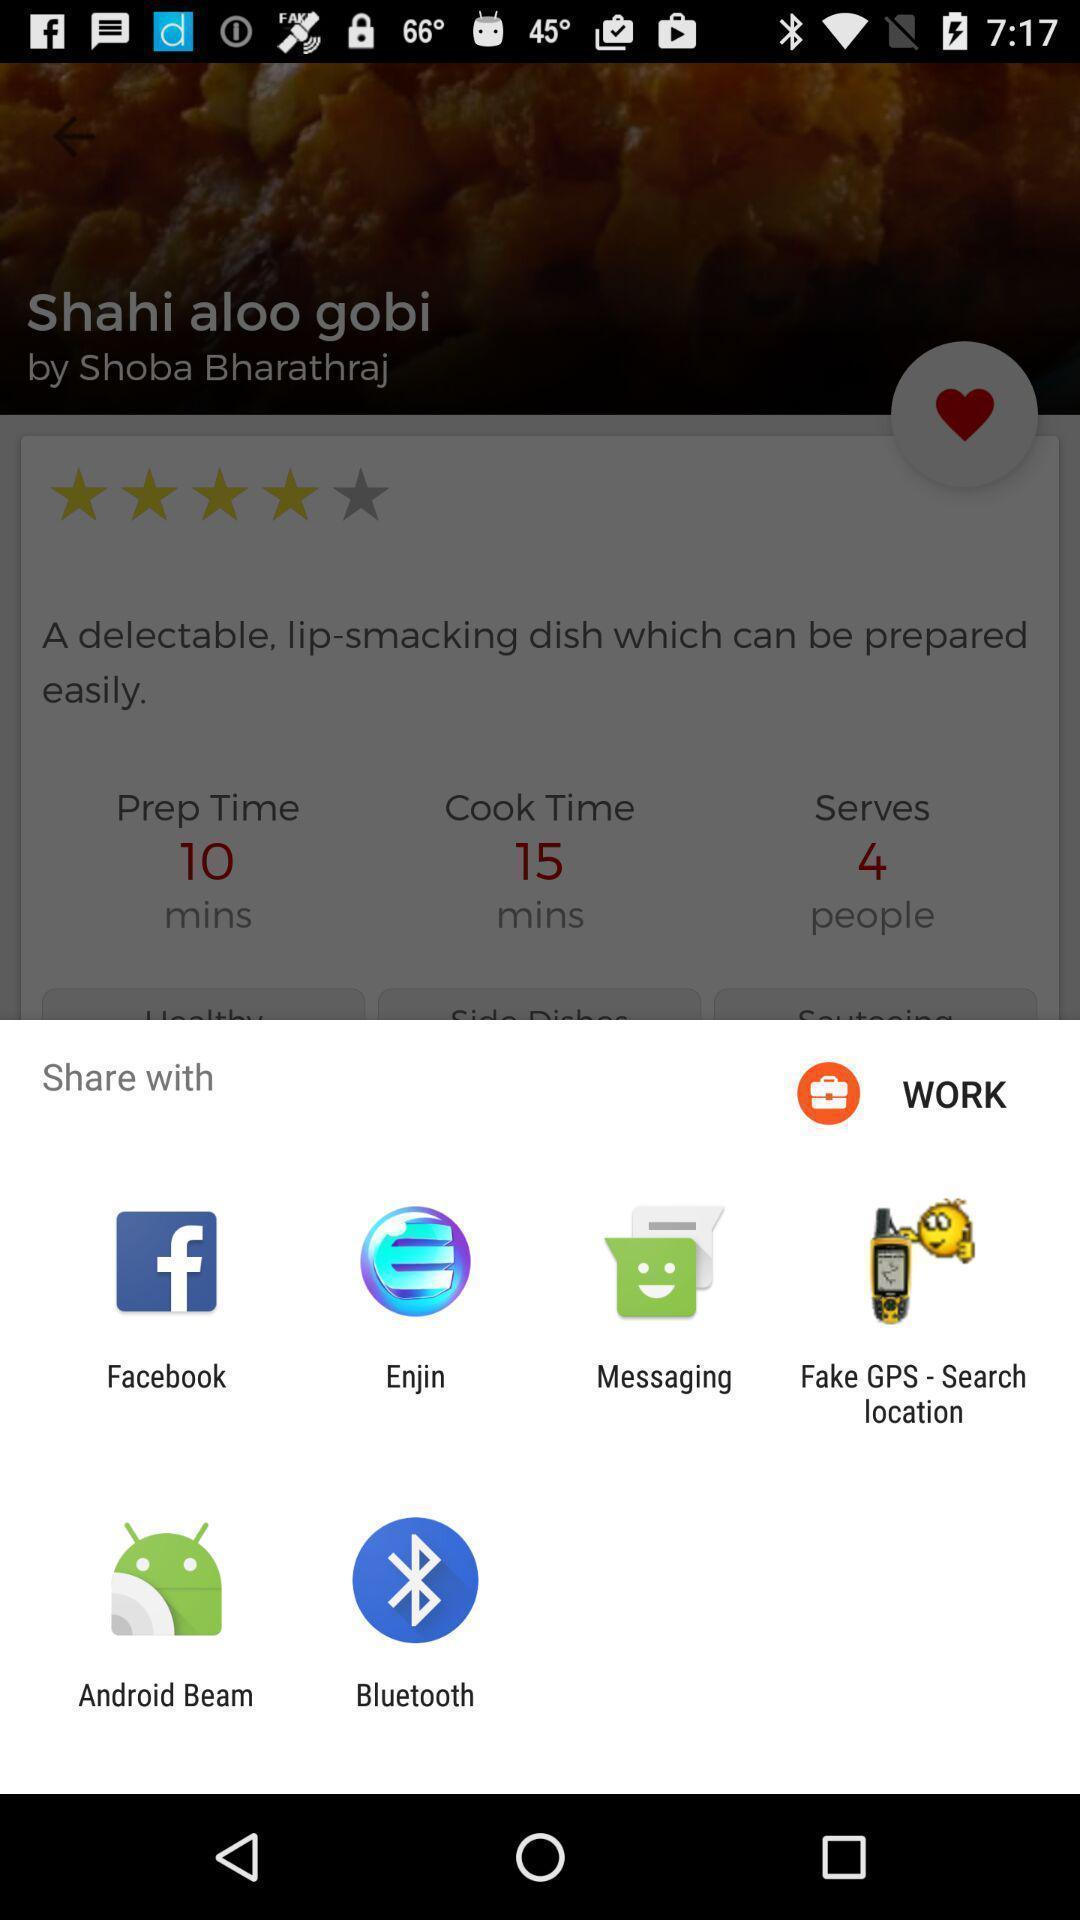What is the overall content of this screenshot? Share information with different apps. 